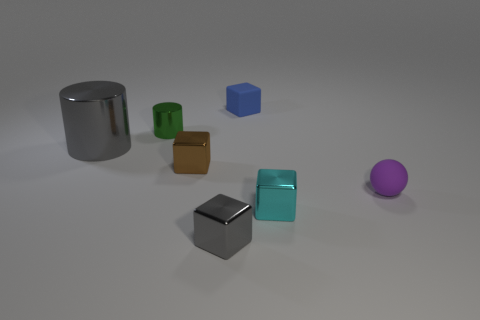There is a gray object behind the matte thing right of the tiny matte cube; what is its material?
Offer a very short reply. Metal. What is the size of the cube on the left side of the gray thing that is in front of the gray metal object that is left of the green shiny object?
Your answer should be compact. Small. How many other tiny things are the same material as the brown object?
Give a very brief answer. 3. What is the color of the small rubber object in front of the shiny object on the left side of the small cylinder?
Ensure brevity in your answer.  Purple. What number of things are small blue metallic things or small objects left of the brown cube?
Keep it short and to the point. 1. Are there any big objects of the same color as the big cylinder?
Offer a very short reply. No. What number of blue objects are either tiny metal things or metallic blocks?
Make the answer very short. 0. How many other things are there of the same size as the brown cube?
Your answer should be compact. 5. What number of small objects are either blue blocks or purple balls?
Your response must be concise. 2. Do the purple matte thing and the metal cylinder that is on the right side of the big cylinder have the same size?
Keep it short and to the point. Yes. 